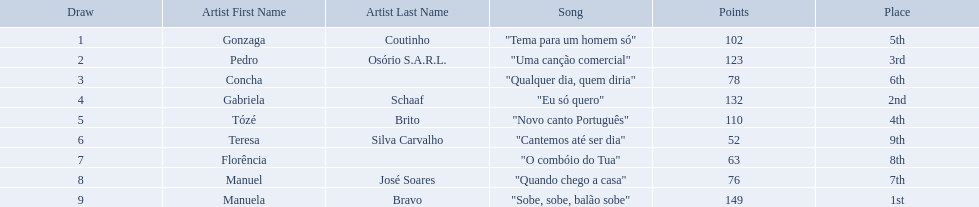What song place second in the contest? "Eu só quero". Who sang eu so quero? Gabriela Schaaf. 